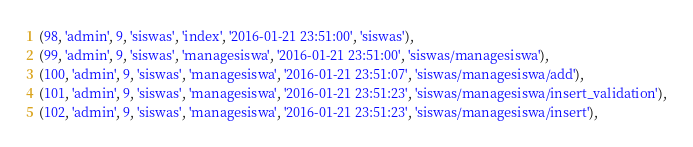Convert code to text. <code><loc_0><loc_0><loc_500><loc_500><_SQL_>(98, 'admin', 9, 'siswas', 'index', '2016-01-21 23:51:00', 'siswas'),
(99, 'admin', 9, 'siswas', 'managesiswa', '2016-01-21 23:51:00', 'siswas/managesiswa'),
(100, 'admin', 9, 'siswas', 'managesiswa', '2016-01-21 23:51:07', 'siswas/managesiswa/add'),
(101, 'admin', 9, 'siswas', 'managesiswa', '2016-01-21 23:51:23', 'siswas/managesiswa/insert_validation'),
(102, 'admin', 9, 'siswas', 'managesiswa', '2016-01-21 23:51:23', 'siswas/managesiswa/insert'),</code> 